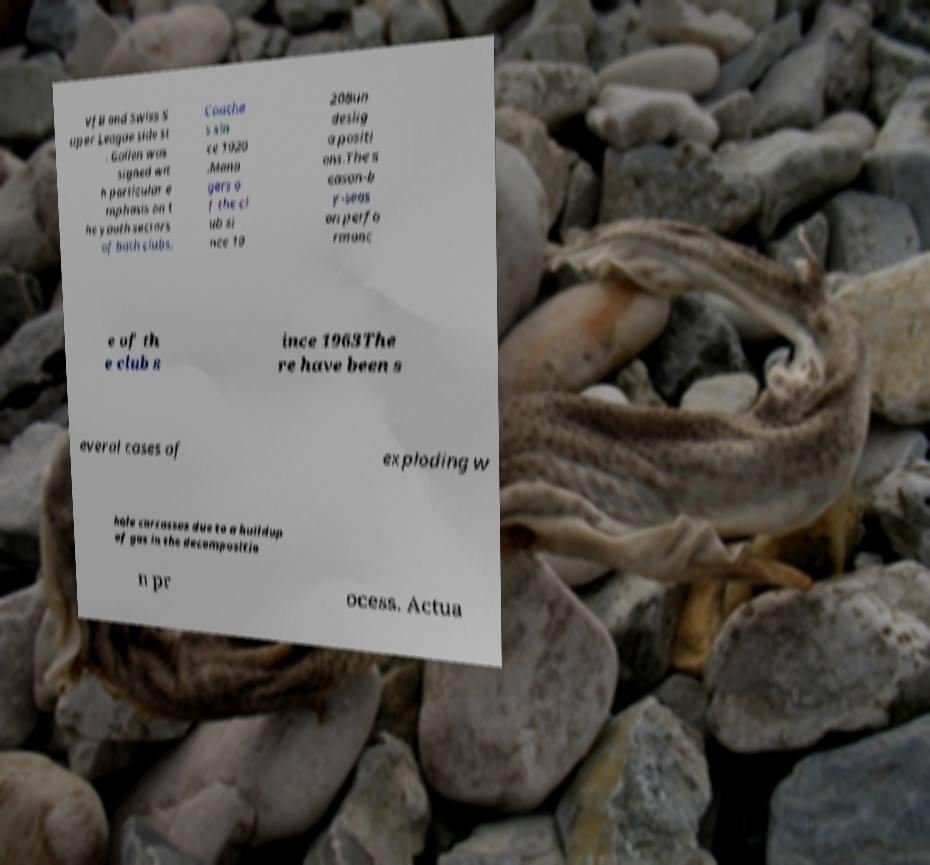What messages or text are displayed in this image? I need them in a readable, typed format. VfB and Swiss S uper League side St . Gallen was signed wit h particular e mphasis on t he youth sectors of both clubs. Coache s sin ce 1920 .Mana gers o f the cl ub si nce 19 20Bun deslig a positi ons.The s eason-b y-seas on perfo rmanc e of th e club s ince 1963The re have been s everal cases of exploding w hale carcasses due to a buildup of gas in the decompositio n pr ocess. Actua 